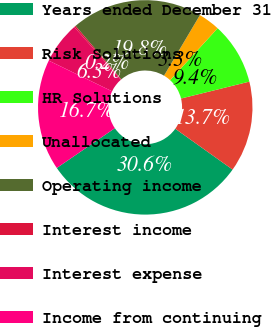<chart> <loc_0><loc_0><loc_500><loc_500><pie_chart><fcel>Years ended December 31<fcel>Risk Solutions<fcel>HR Solutions<fcel>Unallocated<fcel>Operating income<fcel>Interest income<fcel>Interest expense<fcel>Income from continuing<nl><fcel>30.59%<fcel>13.71%<fcel>9.35%<fcel>3.28%<fcel>19.78%<fcel>0.24%<fcel>6.31%<fcel>16.74%<nl></chart> 